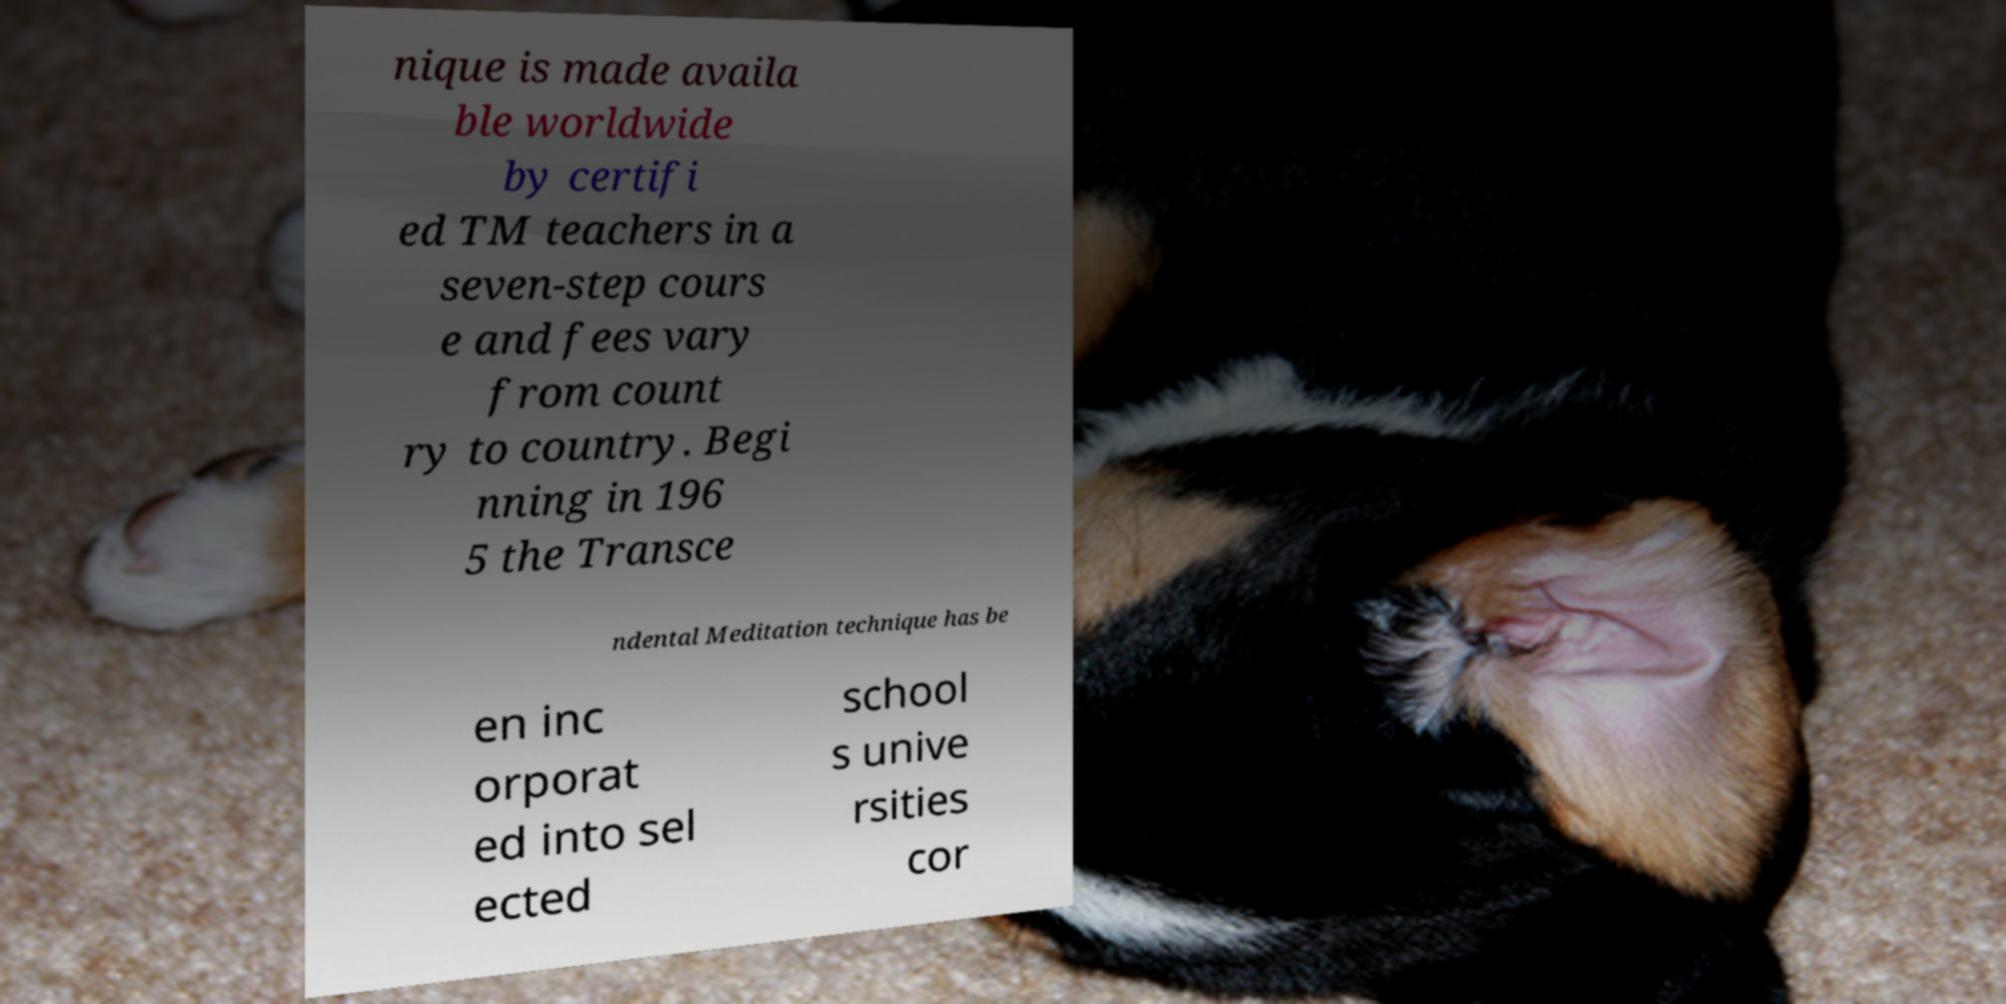Can you read and provide the text displayed in the image?This photo seems to have some interesting text. Can you extract and type it out for me? nique is made availa ble worldwide by certifi ed TM teachers in a seven-step cours e and fees vary from count ry to country. Begi nning in 196 5 the Transce ndental Meditation technique has be en inc orporat ed into sel ected school s unive rsities cor 